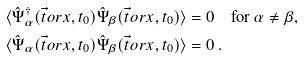<formula> <loc_0><loc_0><loc_500><loc_500>\langle \hat { \Psi } ^ { \dagger } _ { \alpha } ( \vec { t } o r { x } , t _ { 0 } ) \hat { \Psi } _ { \beta } ( \vec { t } o r { x } , t _ { 0 } ) \rangle & = 0 \quad \text {for $\alpha\neq\beta$,} \\ \langle \hat { \Psi } _ { \alpha } ( \vec { t } o r { x } , t _ { 0 } ) \hat { \Psi } _ { \beta } ( \vec { t } o r { x } , t _ { 0 } ) \rangle & = 0 \, .</formula> 